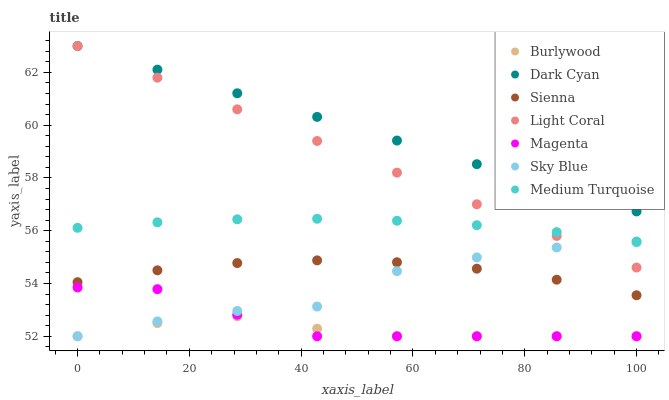Does Burlywood have the minimum area under the curve?
Answer yes or no. Yes. Does Dark Cyan have the maximum area under the curve?
Answer yes or no. Yes. Does Light Coral have the minimum area under the curve?
Answer yes or no. No. Does Light Coral have the maximum area under the curve?
Answer yes or no. No. Is Dark Cyan the smoothest?
Answer yes or no. Yes. Is Sky Blue the roughest?
Answer yes or no. Yes. Is Burlywood the smoothest?
Answer yes or no. No. Is Burlywood the roughest?
Answer yes or no. No. Does Burlywood have the lowest value?
Answer yes or no. Yes. Does Light Coral have the lowest value?
Answer yes or no. No. Does Dark Cyan have the highest value?
Answer yes or no. Yes. Does Burlywood have the highest value?
Answer yes or no. No. Is Burlywood less than Medium Turquoise?
Answer yes or no. Yes. Is Light Coral greater than Burlywood?
Answer yes or no. Yes. Does Sky Blue intersect Magenta?
Answer yes or no. Yes. Is Sky Blue less than Magenta?
Answer yes or no. No. Is Sky Blue greater than Magenta?
Answer yes or no. No. Does Burlywood intersect Medium Turquoise?
Answer yes or no. No. 